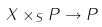Convert formula to latex. <formula><loc_0><loc_0><loc_500><loc_500>X \times _ { S } P \rightarrow P</formula> 